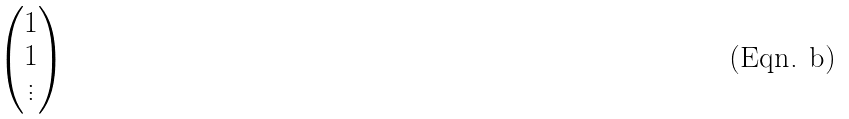<formula> <loc_0><loc_0><loc_500><loc_500>\begin{pmatrix} 1 \\ 1 \\ \vdots \end{pmatrix}</formula> 